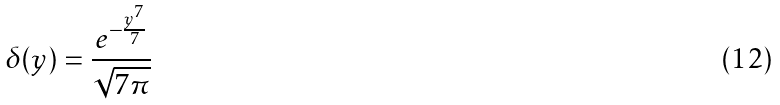<formula> <loc_0><loc_0><loc_500><loc_500>\delta ( y ) = \frac { e ^ { - \frac { y ^ { 7 } } { 7 } } } { \sqrt { 7 \pi } }</formula> 